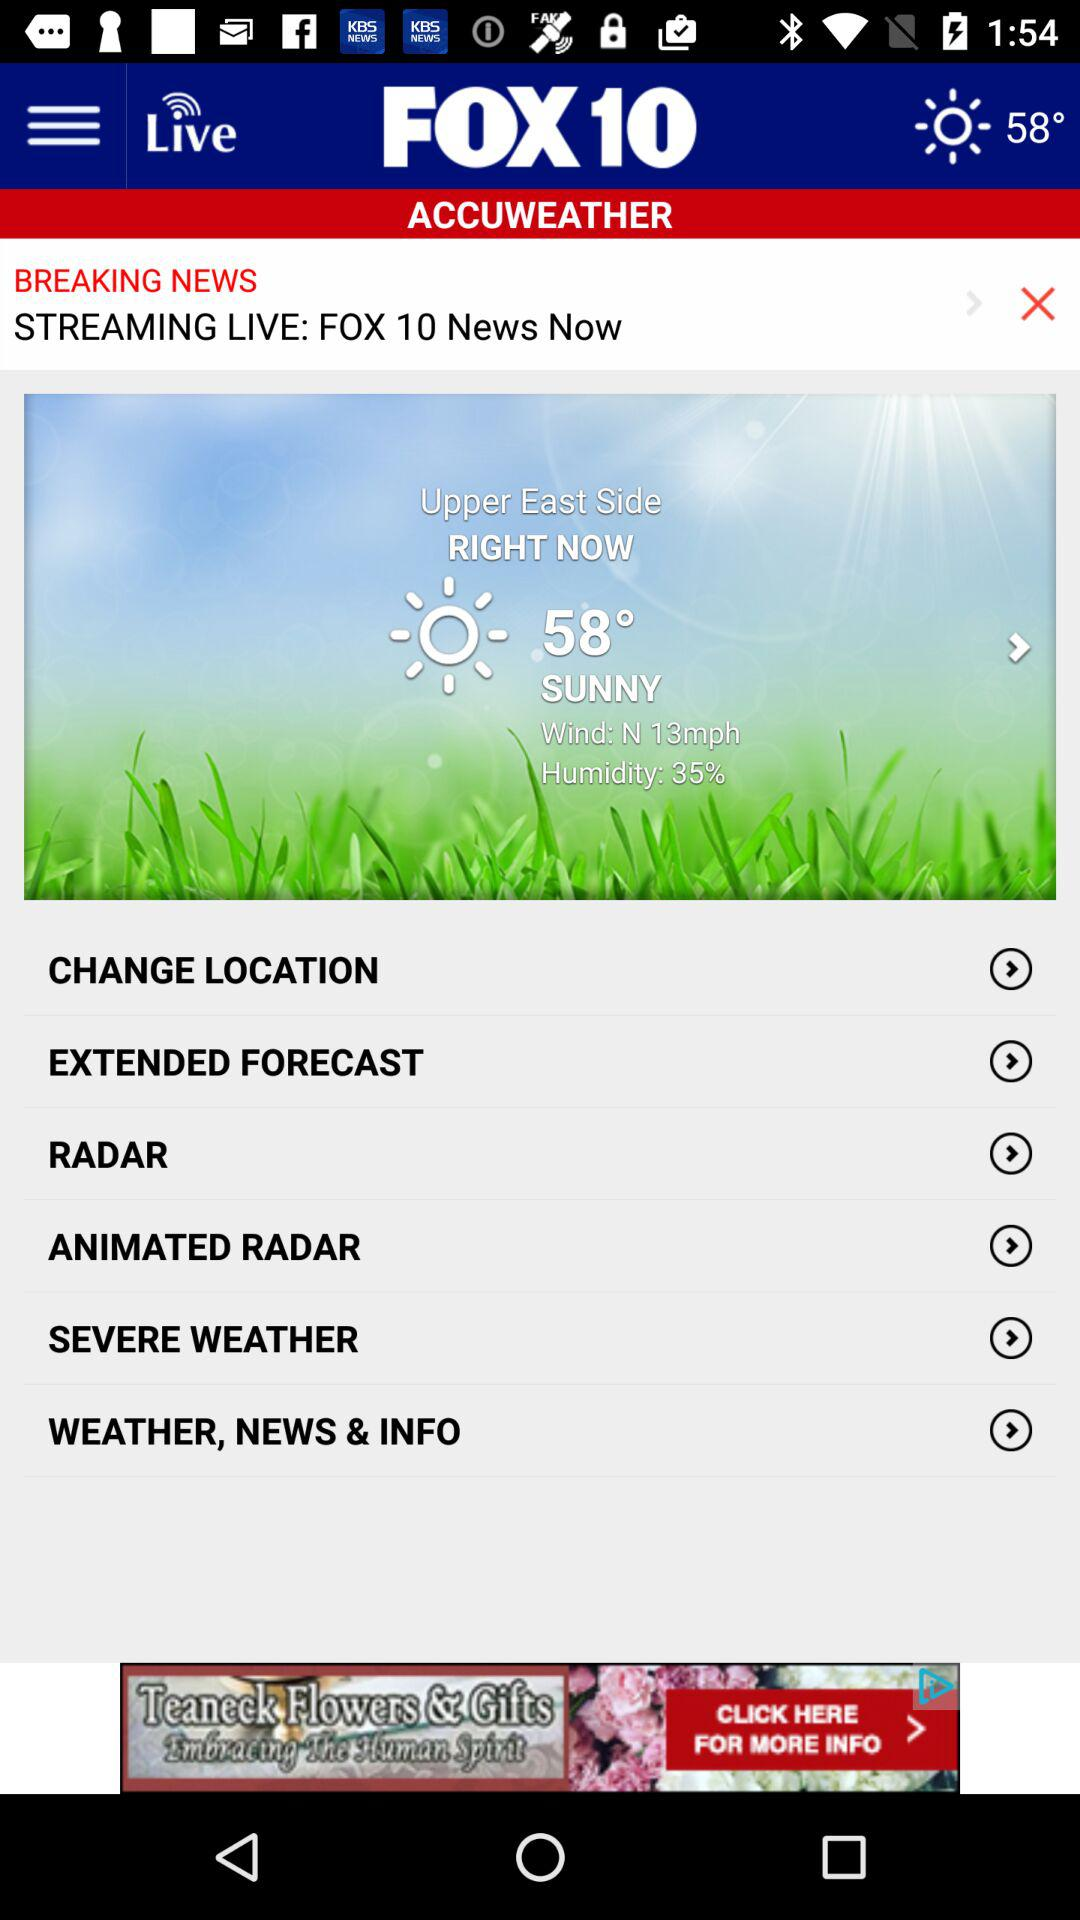How is the weather? The weather is "SUNNY". 